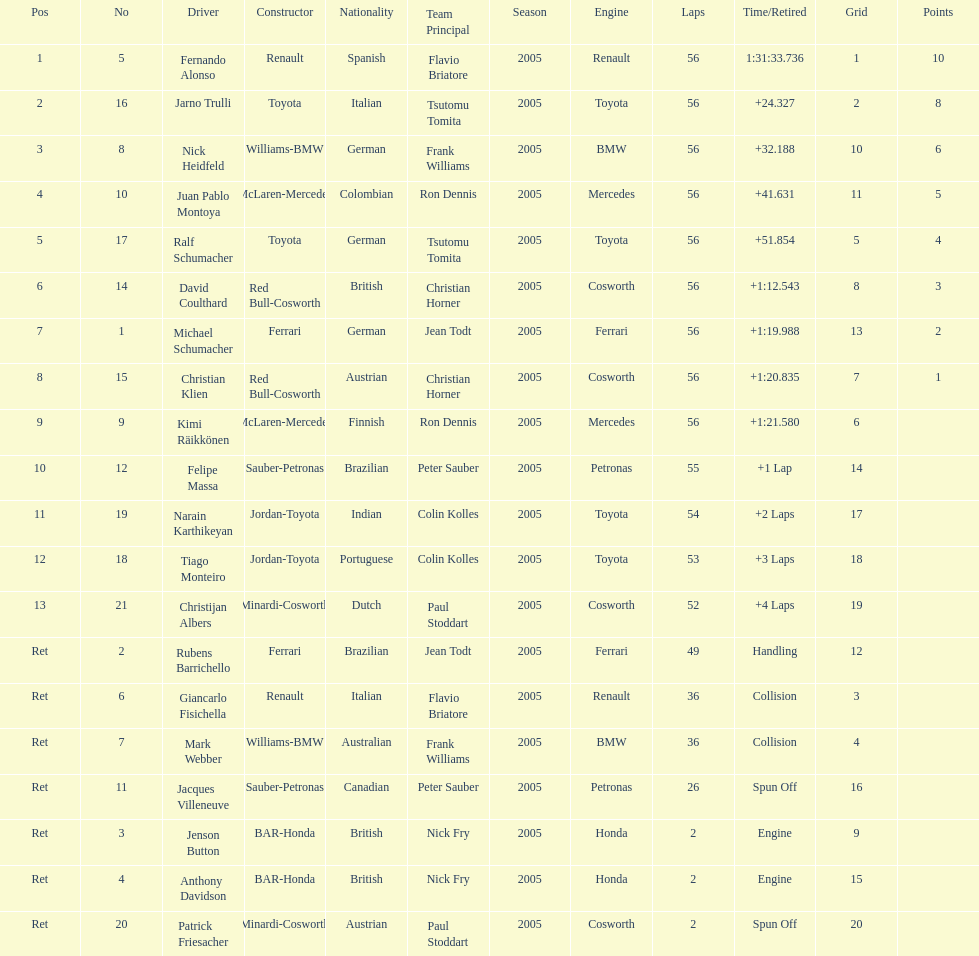How many drivers ended the race early because of engine problems? 2. Parse the full table. {'header': ['Pos', 'No', 'Driver', 'Constructor', 'Nationality', 'Team Principal', 'Season', 'Engine', 'Laps', 'Time/Retired', 'Grid', 'Points'], 'rows': [['1', '5', 'Fernando Alonso', 'Renault', 'Spanish', 'Flavio Briatore', '2005', 'Renault', '56', '1:31:33.736', '1', '10'], ['2', '16', 'Jarno Trulli', 'Toyota', 'Italian', 'Tsutomu Tomita', '2005', 'Toyota', '56', '+24.327', '2', '8'], ['3', '8', 'Nick Heidfeld', 'Williams-BMW', 'German', 'Frank Williams', '2005', 'BMW', '56', '+32.188', '10', '6'], ['4', '10', 'Juan Pablo Montoya', 'McLaren-Mercedes', 'Colombian', 'Ron Dennis', '2005', 'Mercedes', '56', '+41.631', '11', '5'], ['5', '17', 'Ralf Schumacher', 'Toyota', 'German', 'Tsutomu Tomita', '2005', 'Toyota', '56', '+51.854', '5', '4'], ['6', '14', 'David Coulthard', 'Red Bull-Cosworth', 'British', 'Christian Horner', '2005', 'Cosworth', '56', '+1:12.543', '8', '3'], ['7', '1', 'Michael Schumacher', 'Ferrari', 'German', 'Jean Todt', '2005', 'Ferrari', '56', '+1:19.988', '13', '2'], ['8', '15', 'Christian Klien', 'Red Bull-Cosworth', 'Austrian', 'Christian Horner', '2005', 'Cosworth', '56', '+1:20.835', '7', '1'], ['9', '9', 'Kimi Räikkönen', 'McLaren-Mercedes', 'Finnish', 'Ron Dennis', '2005', 'Mercedes', '56', '+1:21.580', '6', ''], ['10', '12', 'Felipe Massa', 'Sauber-Petronas', 'Brazilian', 'Peter Sauber', '2005', 'Petronas', '55', '+1 Lap', '14', ''], ['11', '19', 'Narain Karthikeyan', 'Jordan-Toyota', 'Indian', 'Colin Kolles', '2005', 'Toyota', '54', '+2 Laps', '17', ''], ['12', '18', 'Tiago Monteiro', 'Jordan-Toyota', 'Portuguese', 'Colin Kolles', '2005', 'Toyota', '53', '+3 Laps', '18', ''], ['13', '21', 'Christijan Albers', 'Minardi-Cosworth', 'Dutch', 'Paul Stoddart', '2005', 'Cosworth', '52', '+4 Laps', '19', ''], ['Ret', '2', 'Rubens Barrichello', 'Ferrari', 'Brazilian', 'Jean Todt', '2005', 'Ferrari', '49', 'Handling', '12', ''], ['Ret', '6', 'Giancarlo Fisichella', 'Renault', 'Italian', 'Flavio Briatore', '2005', 'Renault', '36', 'Collision', '3', ''], ['Ret', '7', 'Mark Webber', 'Williams-BMW', 'Australian', 'Frank Williams', '2005', 'BMW', '36', 'Collision', '4', ''], ['Ret', '11', 'Jacques Villeneuve', 'Sauber-Petronas', 'Canadian', 'Peter Sauber', '2005', 'Petronas', '26', 'Spun Off', '16', ''], ['Ret', '3', 'Jenson Button', 'BAR-Honda', 'British', 'Nick Fry', '2005', 'Honda', '2', 'Engine', '9', ''], ['Ret', '4', 'Anthony Davidson', 'BAR-Honda', 'British', 'Nick Fry', '2005', 'Honda', '2', 'Engine', '15', ''], ['Ret', '20', 'Patrick Friesacher', 'Minardi-Cosworth', 'Austrian', 'Paul Stoddart', '2005', 'Cosworth', '2', 'Spun Off', '20', '']]} 